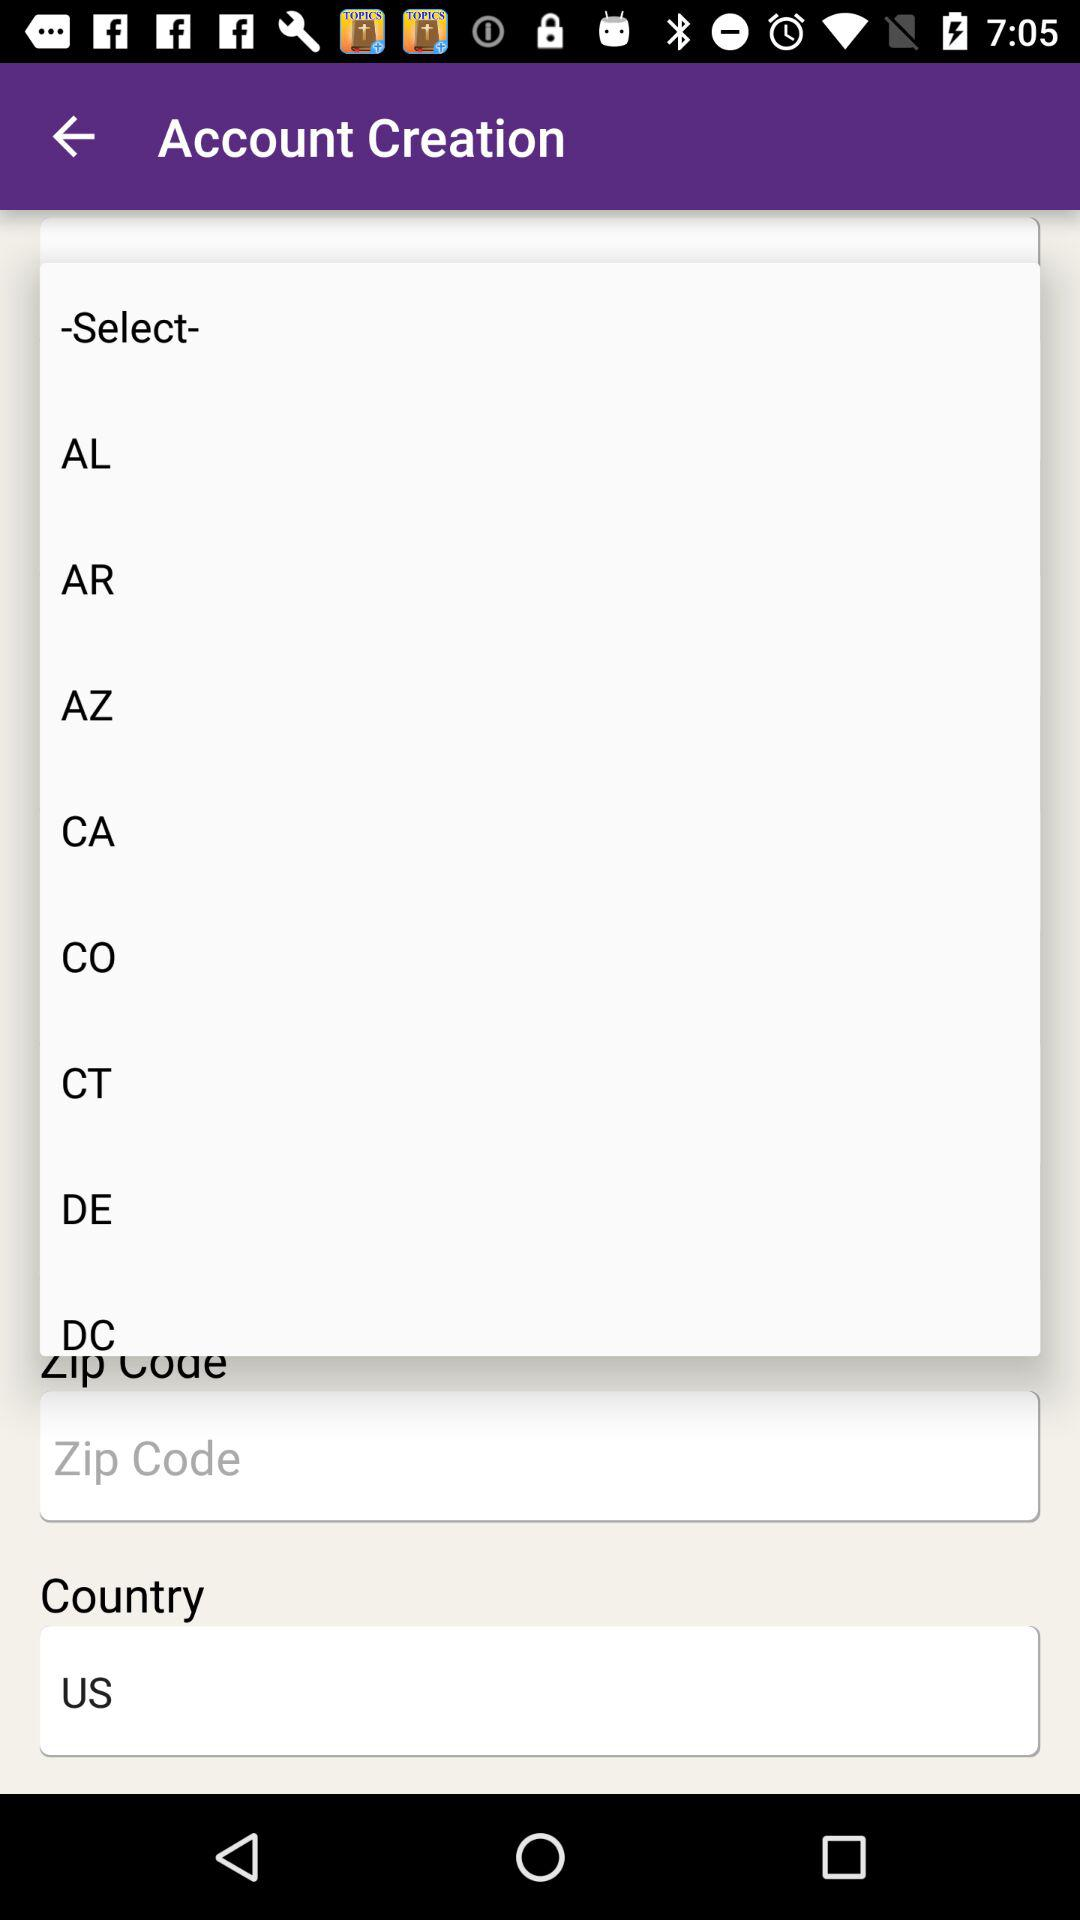What is the entered zip code?
When the provided information is insufficient, respond with <no answer>. <no answer> 